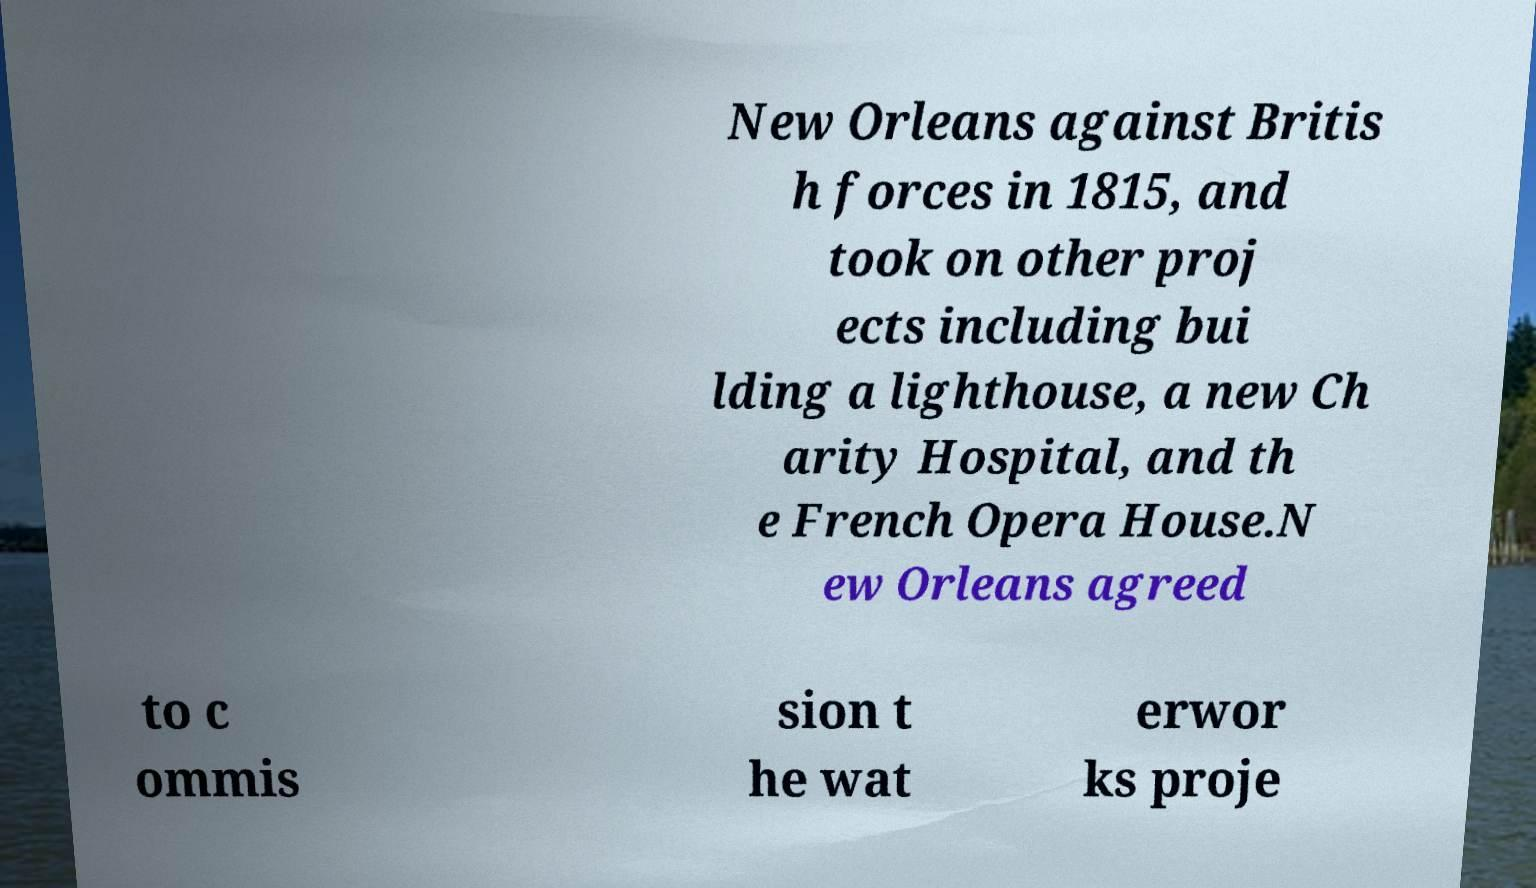Please read and relay the text visible in this image. What does it say? New Orleans against Britis h forces in 1815, and took on other proj ects including bui lding a lighthouse, a new Ch arity Hospital, and th e French Opera House.N ew Orleans agreed to c ommis sion t he wat erwor ks proje 